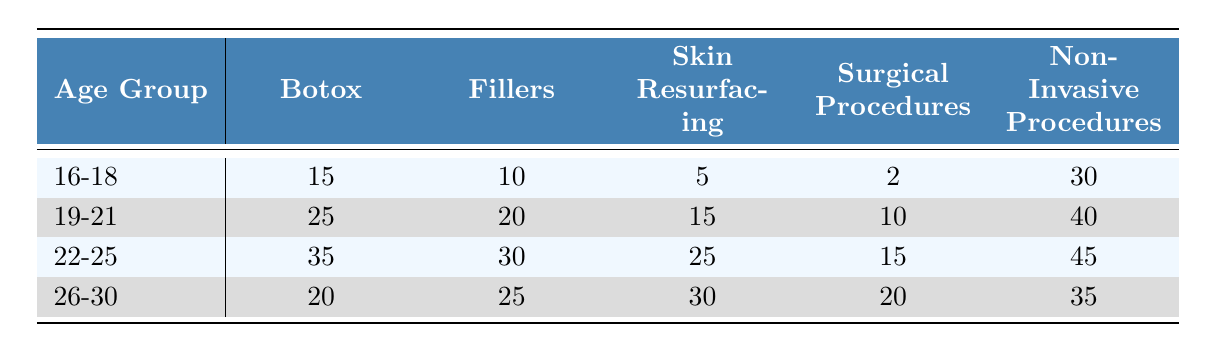What age group has the highest interest in Botox? The interest in Botox is 15 for the 16-18 age group, 25 for the 19-21 age group, 35 for the 22-25 age group, and 20 for the 26-30 age group. The highest value is 35, corresponding to the 22-25 age group.
Answer: 22-25 What is the combined interest in non-invasive procedures for all age groups? The interest levels for non-invasive procedures are 30 (16-18), 40 (19-21), 45 (22-25), and 35 (26-30). Summing these values gives 30 + 40 + 45 + 35 = 150.
Answer: 150 Is the interest in fillers higher for the 22-25 age group than for the 19-21 age group? The interest in fillers for the 22-25 age group is 30, while for the 19-21 age group it is 20. Since 30 is greater than 20, this statement is true.
Answer: Yes Which age group has the least interest in surgical procedures? The interest in surgical procedures is as follows: 2 for the 16-18 age group, 10 for the 19-21 age group, 15 for the 22-25 age group, and 20 for the 26-30 age group. The least value is 2, which is for the 16-18 age group.
Answer: 16-18 What is the average interest in skin resurfacing across all age groups? The values for skin resurfacing are 5 (16-18), 15 (19-21), 25 (22-25), and 30 (26-30). First, sum these values: 5 + 15 + 25 + 30 = 75. There are 4 age groups, so the average is 75 / 4 = 18.75.
Answer: 18.75 In which cosmetic procedure do 19-21 year-olds show the greatest interest? For the 19-21 age group, the interests are: Botox (25), Fillers (20), Skin Resurfacing (15), Surgical Procedures (10), Non-Invasive Procedures (40). The highest value is for Non-Invasive Procedures at 40.
Answer: Non-Invasive Procedures Are young people in the 26-30 age group more interested in fillers than skin resurfacing? The interest in fillers for the 26-30 age group is 25, while for skin resurfacing, it is 30. Since 25 is less than 30, this statement is false.
Answer: No What is the difference in interest for non-invasive procedures between the 22-25 and 19-21 age groups? The interest in non-invasive procedures for the 22-25 age group is 45 and for the 19-21 age group is 40. The difference is 45 - 40 = 5.
Answer: 5 